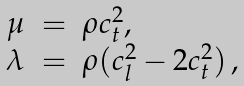Convert formula to latex. <formula><loc_0><loc_0><loc_500><loc_500>\begin{array} { c c l } \mu & = & \rho c _ { t } ^ { 2 } , \\ \lambda & = & \rho ( c _ { l } ^ { 2 } - 2 c _ { t } ^ { 2 } ) \, , \end{array}</formula> 